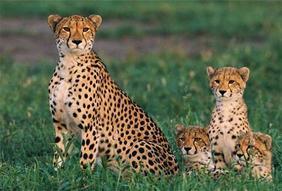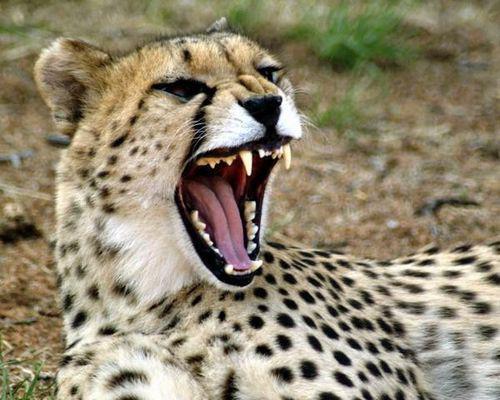The first image is the image on the left, the second image is the image on the right. Considering the images on both sides, is "A total of five cheetahs are shown between the two images." valid? Answer yes or no. Yes. 